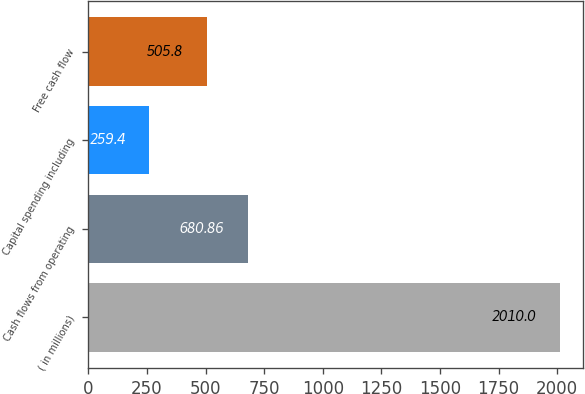<chart> <loc_0><loc_0><loc_500><loc_500><bar_chart><fcel>( in millions)<fcel>Cash flows from operating<fcel>Capital spending including<fcel>Free cash flow<nl><fcel>2010<fcel>680.86<fcel>259.4<fcel>505.8<nl></chart> 